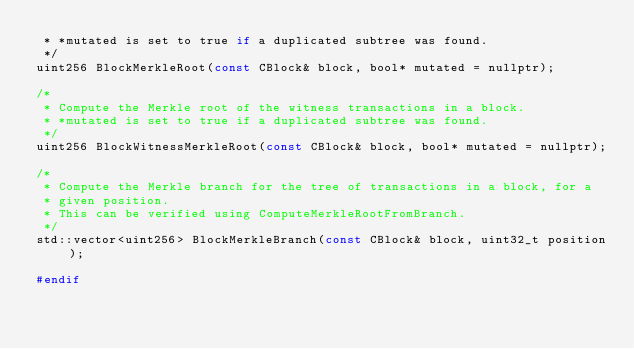<code> <loc_0><loc_0><loc_500><loc_500><_C_> * *mutated is set to true if a duplicated subtree was found.
 */
uint256 BlockMerkleRoot(const CBlock& block, bool* mutated = nullptr);

/*
 * Compute the Merkle root of the witness transactions in a block.
 * *mutated is set to true if a duplicated subtree was found.
 */
uint256 BlockWitnessMerkleRoot(const CBlock& block, bool* mutated = nullptr);

/*
 * Compute the Merkle branch for the tree of transactions in a block, for a
 * given position.
 * This can be verified using ComputeMerkleRootFromBranch.
 */
std::vector<uint256> BlockMerkleBranch(const CBlock& block, uint32_t position);

#endif
</code> 